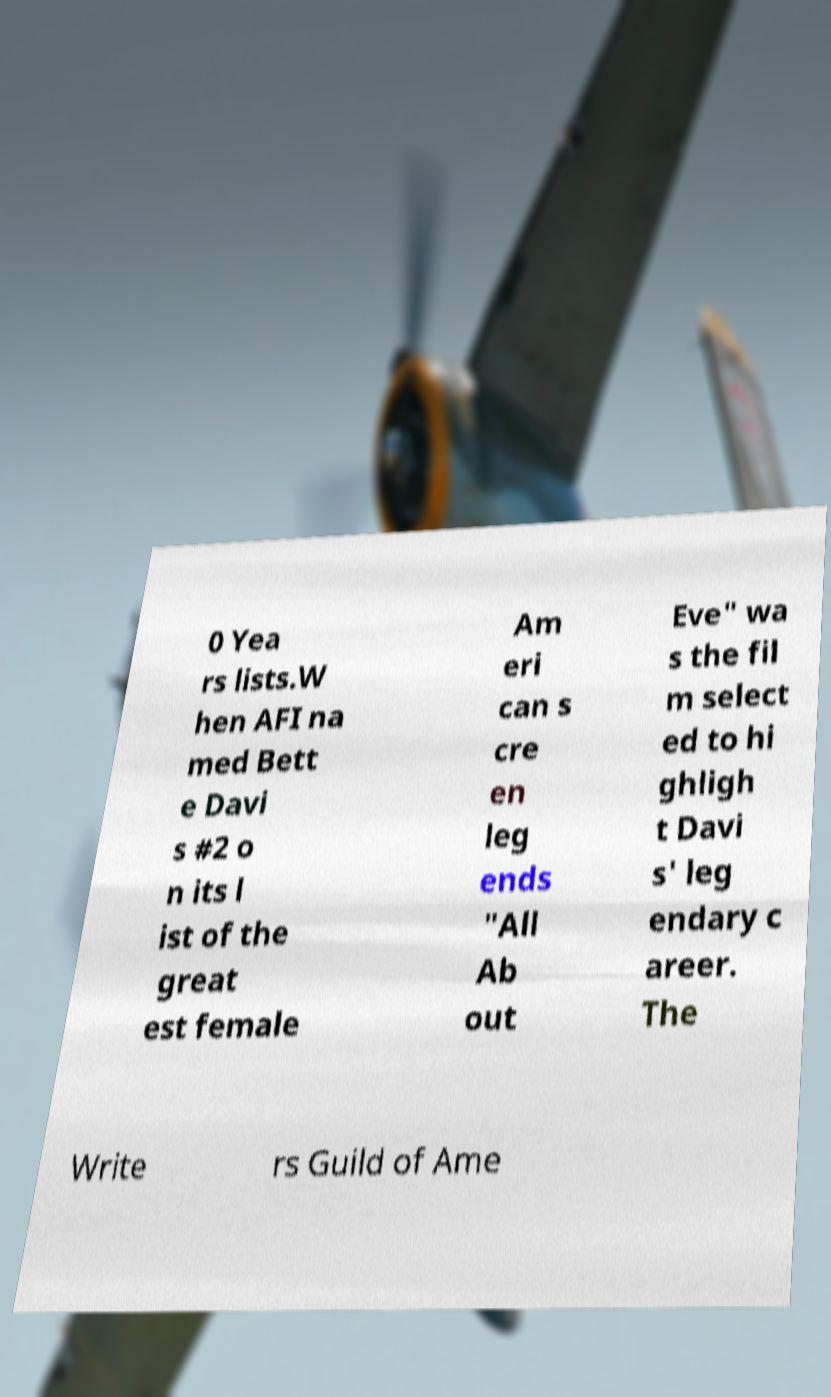I need the written content from this picture converted into text. Can you do that? 0 Yea rs lists.W hen AFI na med Bett e Davi s #2 o n its l ist of the great est female Am eri can s cre en leg ends "All Ab out Eve" wa s the fil m select ed to hi ghligh t Davi s' leg endary c areer. The Write rs Guild of Ame 